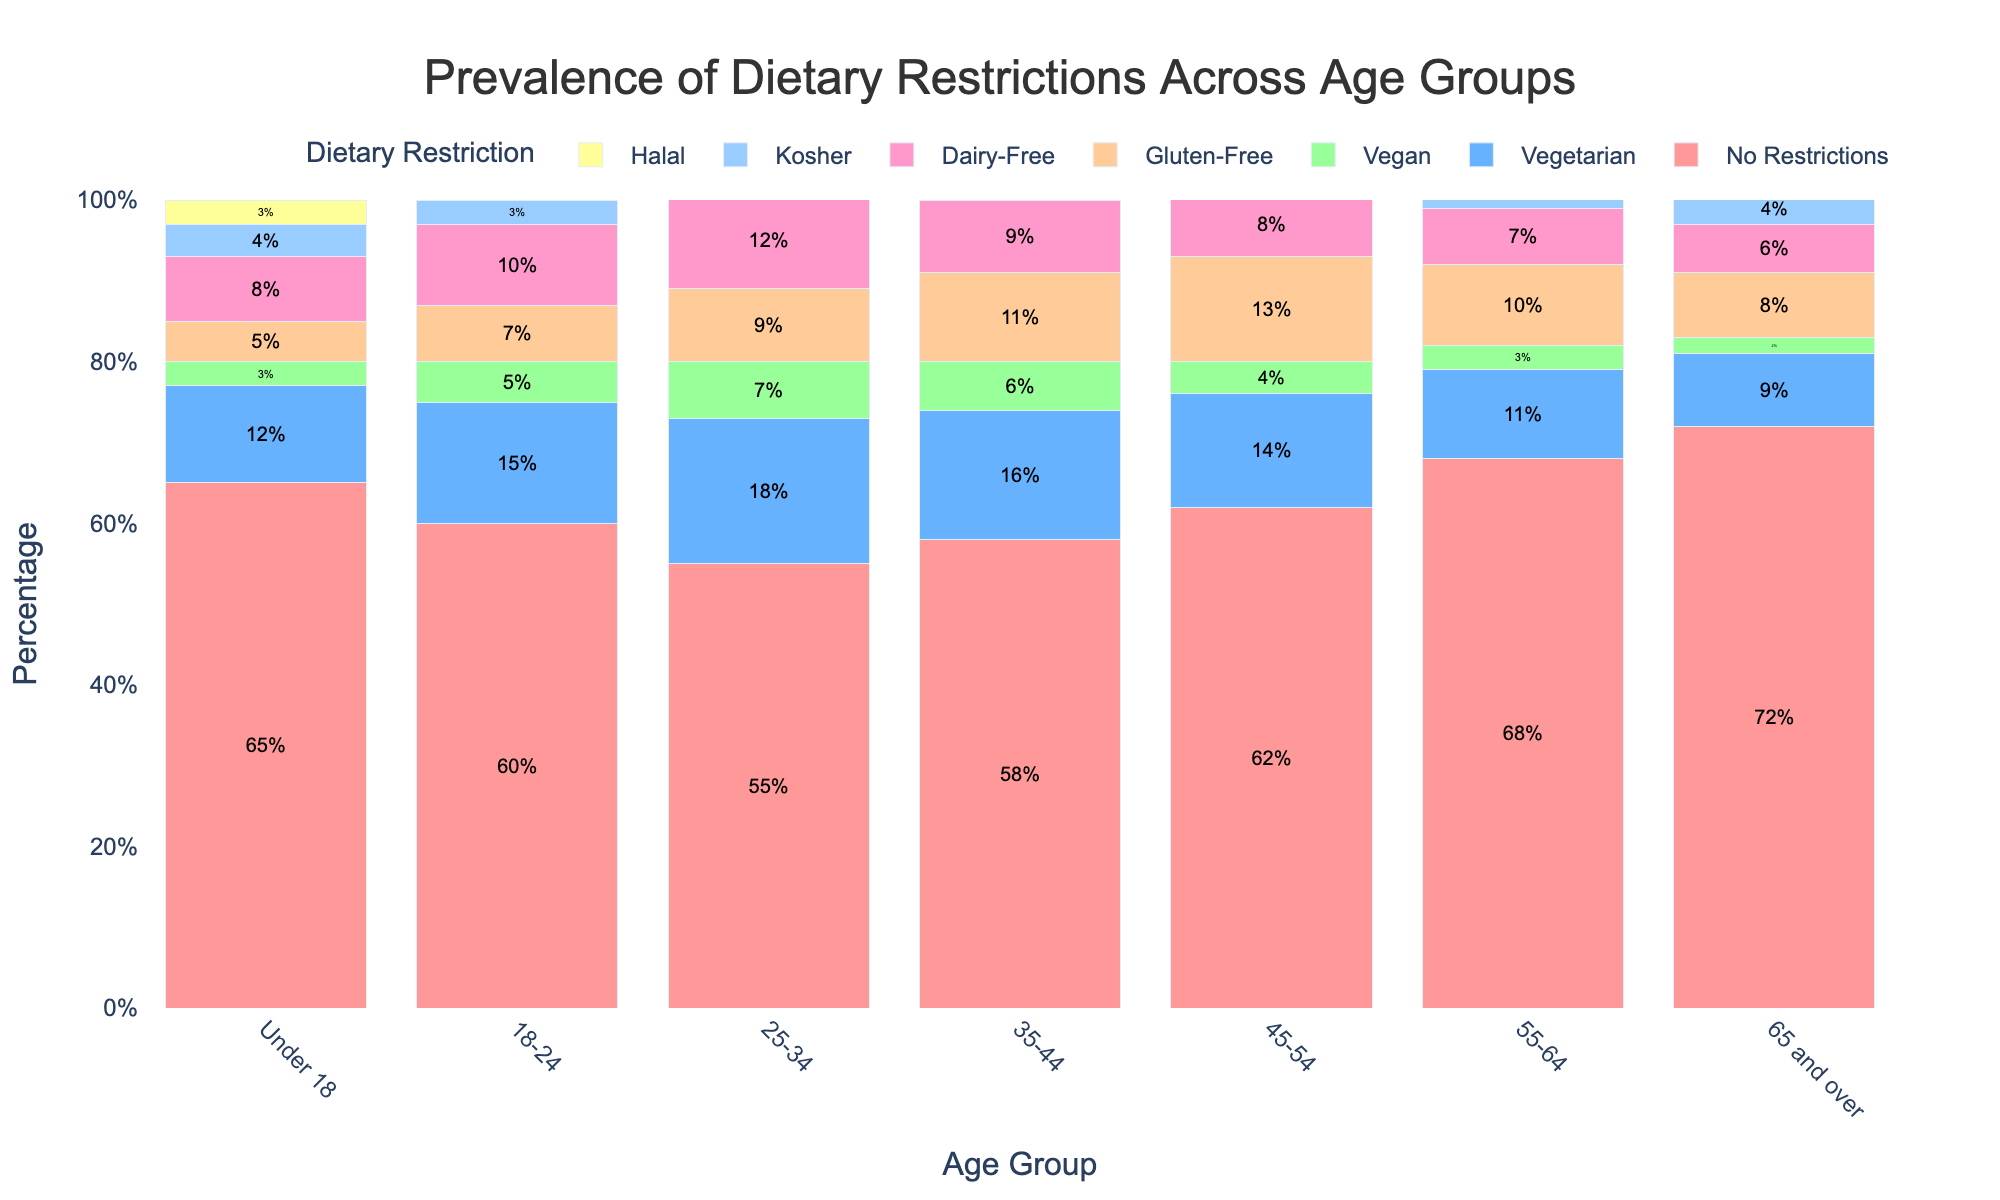Which age group has the highest prevalence of no dietary restrictions? The bar labeled "No Restrictions" is highest for the "65 and over" age group.
Answer: 65 and over Which dietary restriction is most common among the 25-34 age group? Among the different bars for dietary restrictions in the 25-34 age group, the bar labeled "Vegetarian" is the highest.
Answer: Vegetarian Compare the prevalence of veganism between the Under 18 age group and the 65 and over age group. The bar for "Vegan" is 3% for the Under 18 group and 2% for the 65 and over group. Thus, the prevalence of veganism is higher in the Under 18 group.
Answer: Under 18 What is the combined prevalence of gluten-free and dairy-free diets for the 35-44 age group? The "Gluten-Free" is 11% and the "Dairy-Free" is 9% in the 35-44 age group. Summing these gives 11% + 9% = 20%.
Answer: 20% How does the prevalence of halal dietary restrictions vary between the 18-24 and the 55-64 age groups? The bar for "Halal" is 4% for the 18-24 age group and 2% for the 55-64 age group. The prevalence is higher in the 18-24 age group.
Answer: 18-24 What is the difference in the prevalence of kosher diets between the 45-54 and Under 18 age groups? The "Kosher" bar is 6% for the 45-54 age group and 4% for the Under 18 group. The difference is 6% - 4% = 2%.
Answer: 2% Which age group shows the least variety in dietary restrictions? The 65 and over age group has the tallest bar for "No Restrictions" and generally shorter bars for other dietary restrictions, indicating less variety.
Answer: 65 and over What is the total percentage of people with some form of dietary restriction in the 18-24 age group? The complementary of "No Restrictions" for the 18-24 age group is 100% - 60% = 40%.
Answer: 40% Compare the height of the vegetarian bar between the Under 18 and the 25-34 age groups. The vegetarian bar for the Under 18 age group is 12%, while for the 25-34 age group it is 18%. The bar is higher for the 25-34 age group.
Answer: 25-34 Is there any age group where more than 70% of the people have no dietary restrictions? The bar for "No Restrictions" exceeds 70% only for the 65 and over age group.
Answer: Yes, 65 and over 